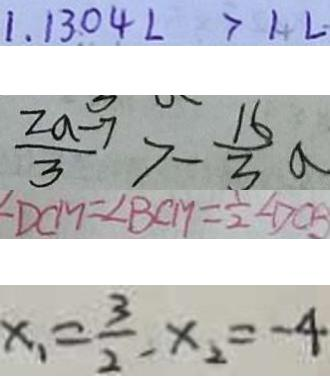<formula> <loc_0><loc_0><loc_500><loc_500>1 . 1 3 0 4 L > 1 L 
 \frac { 2 a - 7 } { 3 } > - \frac { 1 6 } { 3 } a 
 \angle D C M = \angle B C M = \frac { 1 } { 2 } \angle D C B 
 x _ { 1 } = \frac { 3 } { 2 } , x _ { 2 } = - 4</formula> 